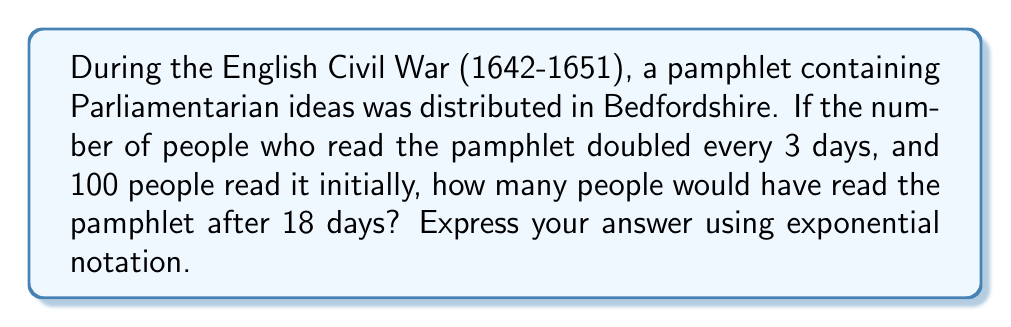Show me your answer to this math problem. Let's approach this step-by-step:

1) First, we need to identify the key components of the exponential function:
   - Initial value (a): 100 people
   - Growth factor (r): 2 (doubles every 3 days)
   - Time (t): 18 days

2) The general form of an exponential growth function is:
   $$ P(t) = a \cdot r^{t/p} $$
   Where:
   - P(t) is the population at time t
   - a is the initial population
   - r is the growth factor
   - t is the time elapsed
   - p is the time period for each growth factor application

3) In this case, p = 3 days (as it doubles every 3 days)

4) Plugging in our values:
   $$ P(18) = 100 \cdot 2^{18/3} $$

5) Simplify the exponent:
   $$ P(18) = 100 \cdot 2^6 $$

6) Calculate $2^6$:
   $$ P(18) = 100 \cdot 64 $$

7) Multiply:
   $$ P(18) = 6400 $$

Therefore, after 18 days, 6400 people would have read the pamphlet.
Answer: $6400$ or $100 \cdot 2^6$ 